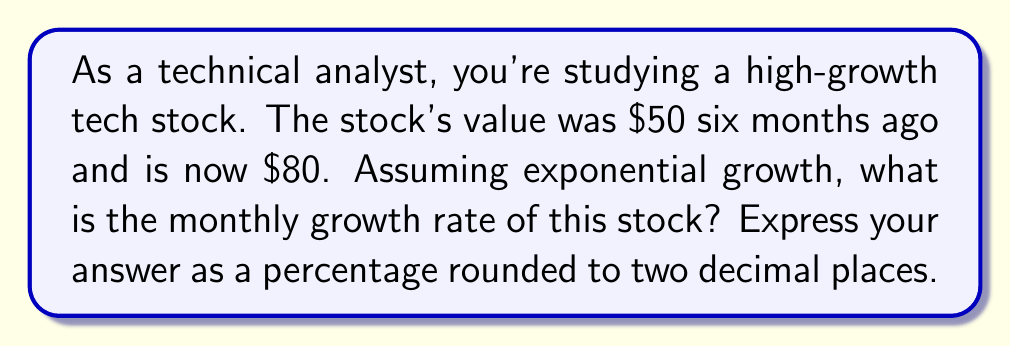Help me with this question. Let's approach this step-by-step using the exponential growth formula:

1) The exponential growth formula is:
   $A = P(1 + r)^t$
   Where:
   $A$ is the final amount
   $P$ is the initial amount
   $r$ is the growth rate (in decimal form)
   $t$ is the time period

2) We know:
   $P = 50$ (initial value)
   $A = 80$ (final value)
   $t = 6$ (months)

3) Let's plug these into our formula:
   $80 = 50(1 + r)^6$

4) Divide both sides by 50:
   $\frac{80}{50} = (1 + r)^6$

5) Simplify:
   $1.6 = (1 + r)^6$

6) Take the 6th root of both sides:
   $\sqrt[6]{1.6} = 1 + r$

7) Subtract 1 from both sides:
   $\sqrt[6]{1.6} - 1 = r$

8) Calculate:
   $r \approx 0.0817$

9) Convert to a percentage:
   $0.0817 \times 100 = 8.17\%$

Therefore, the monthly growth rate is approximately 8.17%.
Answer: 8.17% 